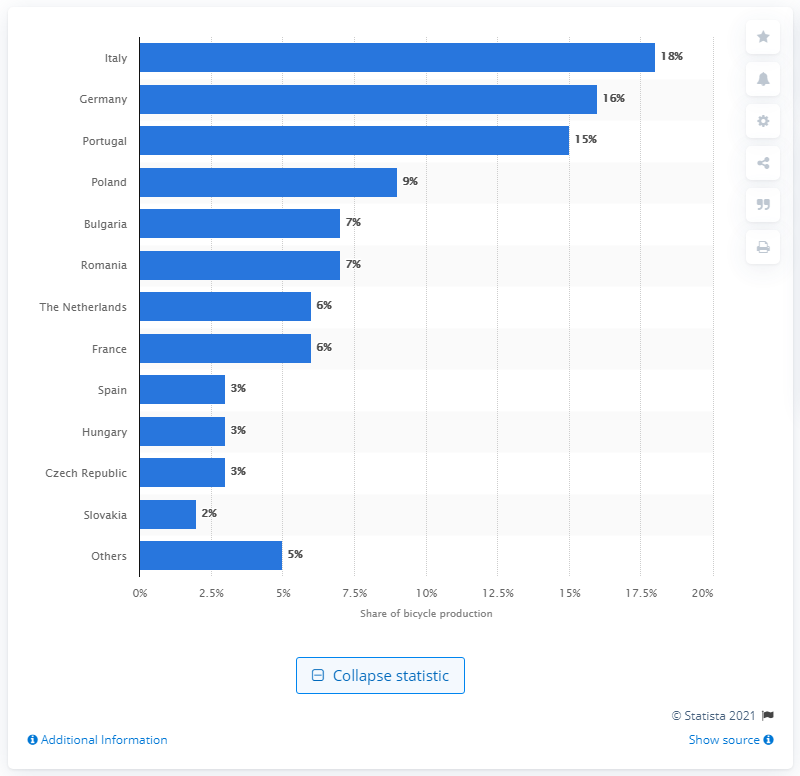Specify some key components in this picture. Italy is the country with the highest share of bicycle production in the European Union. Italy's share of bicycle production in the EU is 18%. 